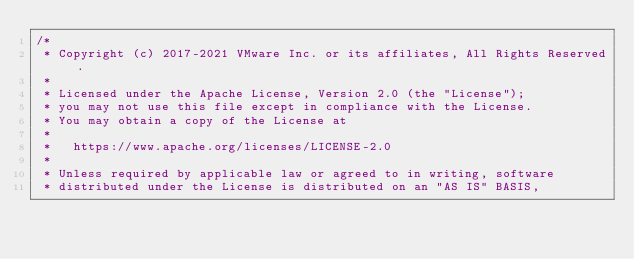<code> <loc_0><loc_0><loc_500><loc_500><_Kotlin_>/*
 * Copyright (c) 2017-2021 VMware Inc. or its affiliates, All Rights Reserved.
 *
 * Licensed under the Apache License, Version 2.0 (the "License");
 * you may not use this file except in compliance with the License.
 * You may obtain a copy of the License at
 *
 *   https://www.apache.org/licenses/LICENSE-2.0
 *
 * Unless required by applicable law or agreed to in writing, software
 * distributed under the License is distributed on an "AS IS" BASIS,</code> 